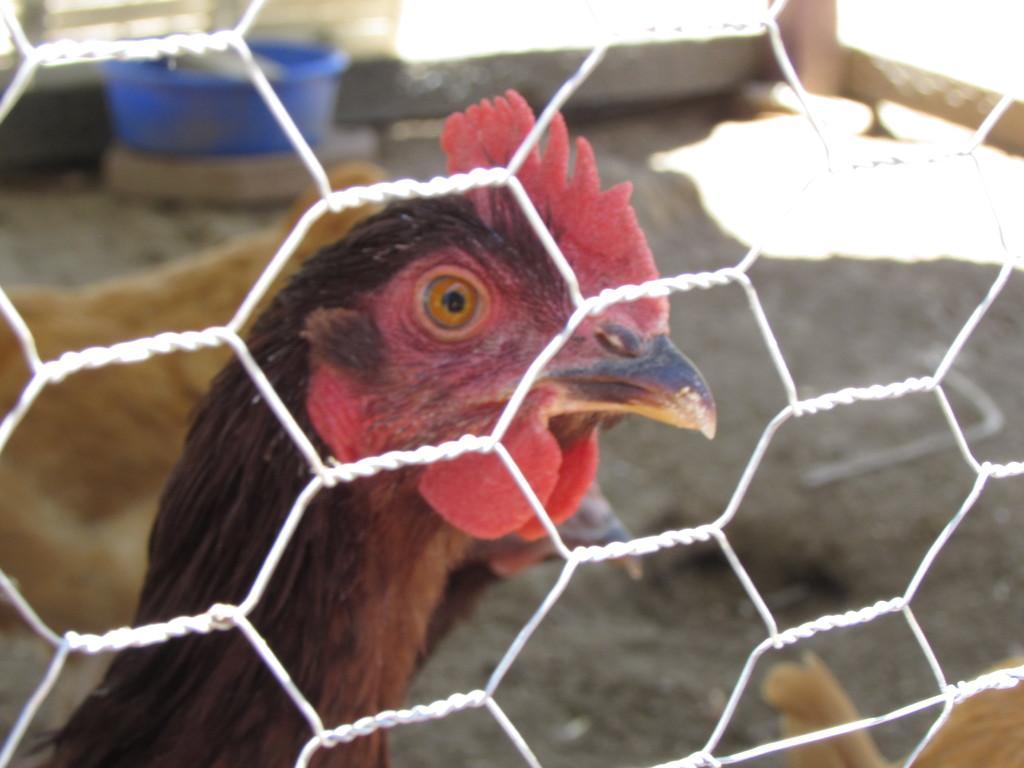Describe this image in one or two sentences. In this image we can see a hen behind a net. 